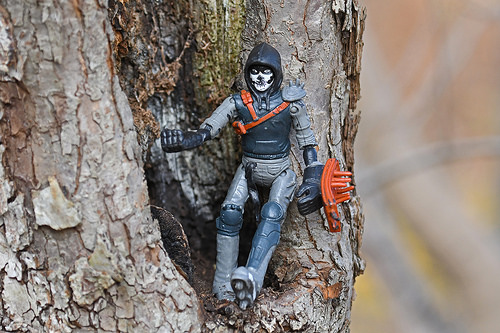<image>
Is the doll on the tree? Yes. Looking at the image, I can see the doll is positioned on top of the tree, with the tree providing support. 